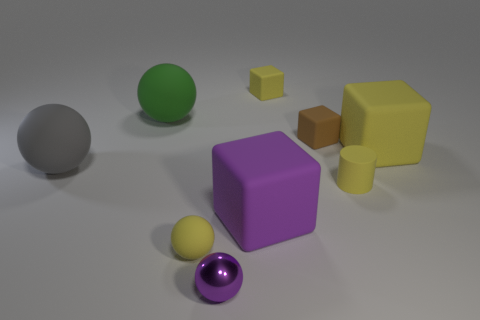What is the color of the rubber ball on the left side of the big green ball?
Your answer should be very brief. Gray. Are there the same number of small brown things that are left of the brown block and big gray matte objects?
Offer a very short reply. No. The tiny yellow object that is both in front of the tiny brown matte cube and to the right of the metal object has what shape?
Your response must be concise. Cylinder. What is the color of the other tiny matte object that is the same shape as the green rubber object?
Offer a terse response. Yellow. Is there anything else that has the same color as the small metallic ball?
Give a very brief answer. Yes. What is the shape of the tiny yellow thing on the right side of the small yellow block that is to the right of the large rubber thing that is in front of the big gray rubber ball?
Make the answer very short. Cylinder. Does the matte sphere in front of the big purple rubber block have the same size as the sphere that is behind the gray rubber sphere?
Offer a terse response. No. What number of small green cylinders have the same material as the small brown cube?
Offer a terse response. 0. There is a tiny matte block in front of the rubber ball behind the large yellow rubber block; how many balls are in front of it?
Provide a succinct answer. 3. Does the large gray thing have the same shape as the big green matte thing?
Your answer should be compact. Yes. 